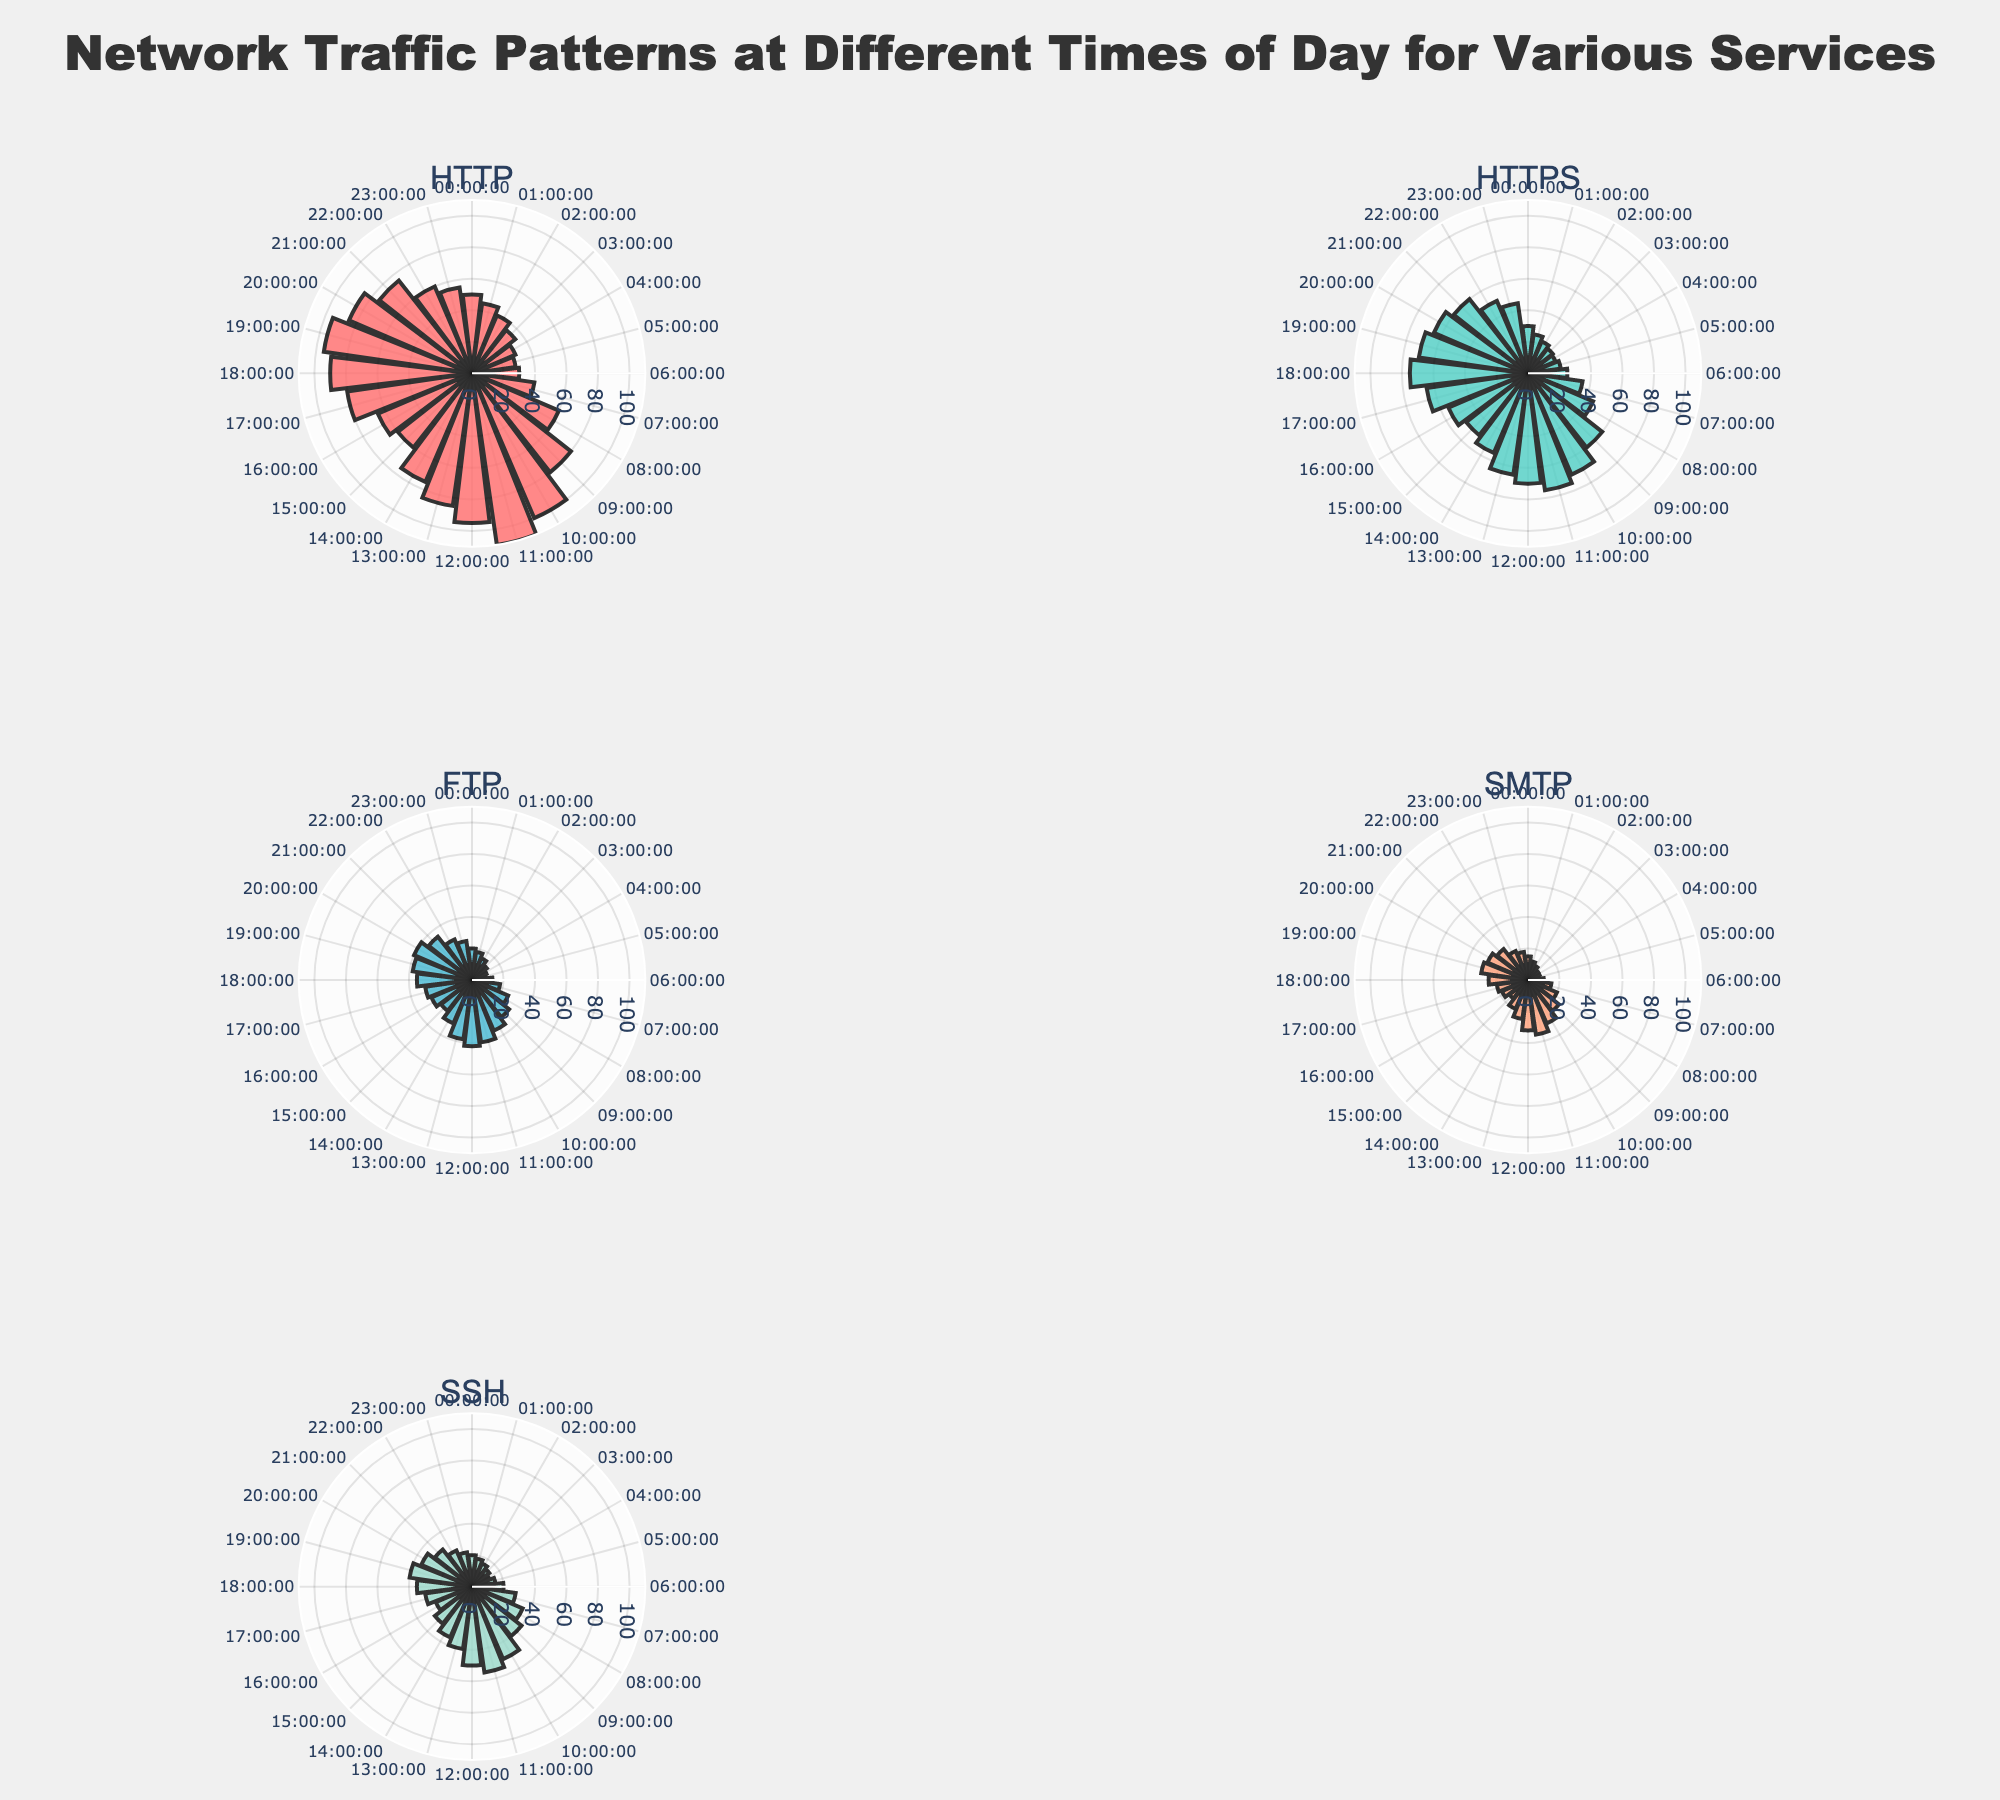Which service shows the highest network traffic at 10:00 AM? Look at the 10:00 AM interval on each subplot and identify which service has the highest bar. The HTTP service shows the highest network traffic at this time.
Answer: HTTP What is the general pattern of HTTPS traffic throughout the day? Look at the HTTPS subplot. The traffic increases from midnight, peaks around 11:00 AM, then decreases slightly in the afternoon and remains relatively stable until night.
Answer: Increase, peak, decrease, then stable Compare the peak network traffic times for HTTP and FTP services. Identify the time of highest traffic on both HTTP's and FTP's subplots. HTTP peaks at 11:00 AM with 110 units, and FTP peaks at 12:00 PM with 42 units.
Answer: 11:00 AM for HTTP, 12:00 PM for FTP Which service maintains the most stable network traffic across the entire day? Examine the subplots to identify which one has the least variation in bar lengths. SMTP and FTP exhibit more stable patterns, but FTP specifically has a minor highest variance overall.
Answer: FTP What is the network traffic for SSH at 3:00 PM and how does it compare to the same time for HTTPS? Look at both SSH and HTTPS subplots at 15:00 (3:00 PM). SSH has 30 units and HTTPS has 50 units, so HTTPS has higher traffic at this time.
Answer: SSH: 30, HTTPS: 50; HTTPS is higher During which time period does SMTP traffic have a sharp increase and start to decline again? Examine the SMTP subplot to identify the time intervals with significant changes. SMTP traffic sharply increases from 07:00 to 11:00, peaking at 11:00 AM, and then declines after 12:00 PM.
Answer: Increases from 07:00 to 11:00, declines after 12:00 If you sum the network traffic for all services at 09:00 AM, what is the total? Sum the values at 09:00 AM for all services. HTTP (80) + HTTPS (60) + FTP (30) + SMTP (25) + SSH (40) = 235 units.
Answer: 235 units At what time does SSH reach its lowest network traffic and what is the value? Look at the SSH subplot and identify the lowest bar. The lowest network traffic for SSH is at 05:00 with 15 units.
Answer: 05:00, 15 units What time of the day is most consistently busy across all services? Look for a time where most subplots show high traffic values. Around 10:00 to 12:00 AM, most services peak, indicating a busy time span.
Answer: 10:00 to 12:00 